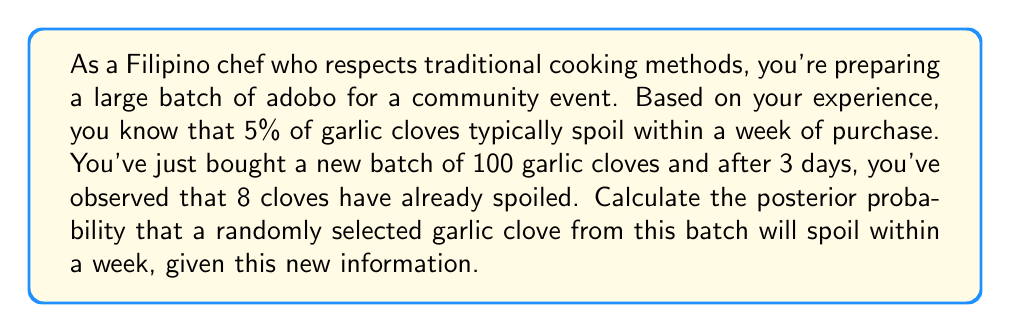Can you answer this question? To solve this problem, we'll use Bayes' theorem and the concept of conjugate priors. Let's break it down step by step:

1. Define our variables:
   $\theta$ = probability of a garlic clove spoiling within a week
   $y$ = number of spoiled cloves observed
   $n$ = total number of cloves observed

2. Prior distribution:
   Based on your experience, the prior probability is 5% or 0.05. We can model this using a Beta distribution:
   $\theta \sim \text{Beta}(a, b)$
   where $a = 5$ and $b = 95$ (these values give us a mean of 0.05)

3. Likelihood:
   The likelihood of observing $y$ spoiled cloves out of $n$ total cloves follows a Binomial distribution:
   $y | \theta \sim \text{Binomial}(n, \theta)$

4. Posterior distribution:
   The posterior distribution is also a Beta distribution (conjugate prior property):
   $\theta | y \sim \text{Beta}(a + y, b + n - y)$

5. Calculate the parameters of the posterior distribution:
   $a_{posterior} = a + y = 5 + 8 = 13$
   $b_{posterior} = b + n - y = 95 + 100 - 8 = 187$

6. The posterior mean (which is our estimate for the probability of spoilage) is:
   $$E[\theta | y] = \frac{a_{posterior}}{a_{posterior} + b_{posterior}} = \frac{13}{13 + 187} = \frac{13}{200}$$

Therefore, the posterior probability that a randomly selected garlic clove from this batch will spoil within a week is $\frac{13}{200} = 0.065$ or 6.5%.
Answer: 0.065 or 6.5% 